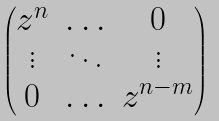<formula> <loc_0><loc_0><loc_500><loc_500>\begin{pmatrix} z ^ { n } & \hdots & 0 \\ \vdots & \ddots & \vdots \\ 0 & \hdots & z ^ { n - m } \end{pmatrix}</formula> 